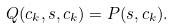<formula> <loc_0><loc_0><loc_500><loc_500>Q ( { c } _ { k } , { s } , { c } _ { k } ) = P ( { s } , { c } _ { k } ) .</formula> 